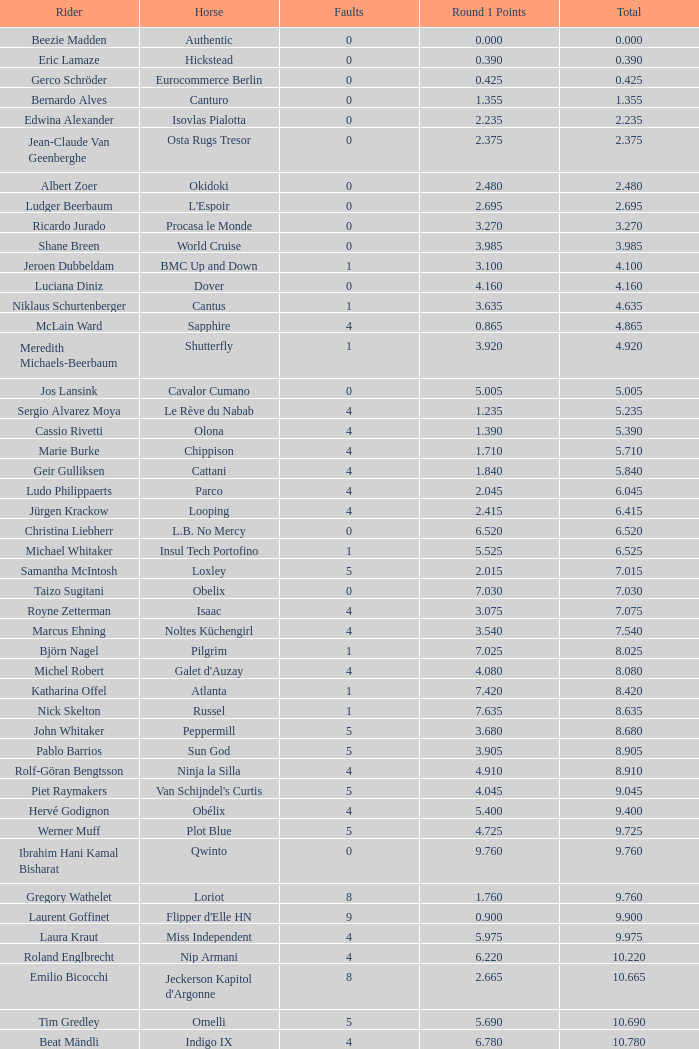Parse the table in full. {'header': ['Rider', 'Horse', 'Faults', 'Round 1 Points', 'Total'], 'rows': [['Beezie Madden', 'Authentic', '0', '0.000', '0.000'], ['Eric Lamaze', 'Hickstead', '0', '0.390', '0.390'], ['Gerco Schröder', 'Eurocommerce Berlin', '0', '0.425', '0.425'], ['Bernardo Alves', 'Canturo', '0', '1.355', '1.355'], ['Edwina Alexander', 'Isovlas Pialotta', '0', '2.235', '2.235'], ['Jean-Claude Van Geenberghe', 'Osta Rugs Tresor', '0', '2.375', '2.375'], ['Albert Zoer', 'Okidoki', '0', '2.480', '2.480'], ['Ludger Beerbaum', "L'Espoir", '0', '2.695', '2.695'], ['Ricardo Jurado', 'Procasa le Monde', '0', '3.270', '3.270'], ['Shane Breen', 'World Cruise', '0', '3.985', '3.985'], ['Jeroen Dubbeldam', 'BMC Up and Down', '1', '3.100', '4.100'], ['Luciana Diniz', 'Dover', '0', '4.160', '4.160'], ['Niklaus Schurtenberger', 'Cantus', '1', '3.635', '4.635'], ['McLain Ward', 'Sapphire', '4', '0.865', '4.865'], ['Meredith Michaels-Beerbaum', 'Shutterfly', '1', '3.920', '4.920'], ['Jos Lansink', 'Cavalor Cumano', '0', '5.005', '5.005'], ['Sergio Alvarez Moya', 'Le Rève du Nabab', '4', '1.235', '5.235'], ['Cassio Rivetti', 'Olona', '4', '1.390', '5.390'], ['Marie Burke', 'Chippison', '4', '1.710', '5.710'], ['Geir Gulliksen', 'Cattani', '4', '1.840', '5.840'], ['Ludo Philippaerts', 'Parco', '4', '2.045', '6.045'], ['Jürgen Krackow', 'Looping', '4', '2.415', '6.415'], ['Christina Liebherr', 'L.B. No Mercy', '0', '6.520', '6.520'], ['Michael Whitaker', 'Insul Tech Portofino', '1', '5.525', '6.525'], ['Samantha McIntosh', 'Loxley', '5', '2.015', '7.015'], ['Taizo Sugitani', 'Obelix', '0', '7.030', '7.030'], ['Royne Zetterman', 'Isaac', '4', '3.075', '7.075'], ['Marcus Ehning', 'Noltes Küchengirl', '4', '3.540', '7.540'], ['Björn Nagel', 'Pilgrim', '1', '7.025', '8.025'], ['Michel Robert', "Galet d'Auzay", '4', '4.080', '8.080'], ['Katharina Offel', 'Atlanta', '1', '7.420', '8.420'], ['Nick Skelton', 'Russel', '1', '7.635', '8.635'], ['John Whitaker', 'Peppermill', '5', '3.680', '8.680'], ['Pablo Barrios', 'Sun God', '5', '3.905', '8.905'], ['Rolf-Göran Bengtsson', 'Ninja la Silla', '4', '4.910', '8.910'], ['Piet Raymakers', "Van Schijndel's Curtis", '5', '4.045', '9.045'], ['Hervé Godignon', 'Obélix', '4', '5.400', '9.400'], ['Werner Muff', 'Plot Blue', '5', '4.725', '9.725'], ['Ibrahim Hani Kamal Bisharat', 'Qwinto', '0', '9.760', '9.760'], ['Gregory Wathelet', 'Loriot', '8', '1.760', '9.760'], ['Laurent Goffinet', "Flipper d'Elle HN", '9', '0.900', '9.900'], ['Laura Kraut', 'Miss Independent', '4', '5.975', '9.975'], ['Roland Englbrecht', 'Nip Armani', '4', '6.220', '10.220'], ['Emilio Bicocchi', "Jeckerson Kapitol d'Argonne", '8', '2.665', '10.665'], ['Tim Gredley', 'Omelli', '5', '5.690', '10.690'], ['Beat Mändli', 'Indigo IX', '4', '6.780', '10.780'], ['Christian Ahlmann', 'Cöster', '8', '4.000', '12.000'], ['Tina Lund', 'Carola', '9', '3.610', '12.610'], ['Max Amaya', 'Church Road', '8', '4.790', '12.790'], ['Álvaro Alfonso de Miranda Neto', 'Nike', '9', '4.235', '13.235'], ['Jesus Garmendia Echeverria', 'Maddock', '8', '5.335', '13.335'], ['Carlos Lopez', 'Instit', '10', '3.620', '13.620'], ['Juan Carlos García', 'Loro Piana Albin III', '5', '9.020', '14.020'], ['Cameron Hanley', 'Siec Hippica Kerman', '9', '5.375', '14.375'], ['Ricardo Kierkegaard', 'Rey Z', '8', '6.805', '14.805'], ['Jill Henselwood', 'Special Ed', '9', '6.165', '15.165'], ['Margie Engle', "Hidden Creek's Quervo Gold", '4', '12.065', '16.065'], ['Judy-Ann Melchoir', 'Grande Dame Z', '9', '7.310', '16.310'], ['Maria Gretzer', 'Spender S', '9', '7.385', '16.385'], ['Billy Twomey', 'Luidam', '9', '7.615', '16.615'], ['Federico Fernandez', 'Bohemio', '8', '9.610', '17.610'], ['Jonella Ligresti', 'Quinta 27', '6', '12.365', '18.365'], ['Ian Millar', 'In Style', '9', '9.370', '18.370'], ['Mikael Forsten', "BMC's Skybreaker", '12', '6.435', '18.435'], ['Sebastian Numminen', 'Sails Away', '13', '5.455', '18.455'], ['Stefan Eder', 'Cartier PSG', '12', '6.535', '18.535'], ['Dirk Demeersman', 'Clinton', '16', '2.755', '18.755'], ['Antonis Petris', 'Gredo la Daviere', '13', '6.300', '19.300'], ['Gunnar Klettenberg', 'Novesta', '9', '10.620', '19.620'], ['Syed Omar Almohdzar', 'Lui', '10', '9.820', '19.820'], ['Tony Andre Hansen', 'Camiro', '13', '7.245', '20.245'], ['Manuel Fernandez Saro', 'Quin Chin', '13', '7.465', '20.465'], ['James Wingrave', 'Agropoint Calira', '14', '6.855', '20.855'], ['Rod Brown', 'Mr. Burns', '9', '12.300', '21.300'], ['Jiri Papousek', 'La Manche T', '13', '8.440', '21.440'], ['Marcela Lobo', 'Joskin', '14', '7.600', '21.600'], ['Yuko Itakura', 'Portvliet', '9', '12.655', '21.655'], ['Zsolt Pirik', 'Havanna', '9', '13.050', '22.050'], ['Fabrice Lyon', 'Jasmine du Perron', '11', '12.760', '23.760'], ['Florian Angot', 'First de Launay', '16', '8.055', '24.055'], ['Peter McMahon', 'Kolora Stud Genoa', '9', '15.195', '24.195'], ['Giuseppe Rolli', 'Jericho de la Vie', '17', '7.910', '24.910'], ['Alberto Michan', 'Chinobampo Lavita', '13', '12.330', '25.330'], ['Hanno Ellermann', 'Poncorde', '17', '8.600', '25.600'], ['Antonio Portela Carneiro', 'Echo de Lessay', '18', '8.565', '26.565'], ['Gerfried Puck', '11th Bleeker', '21', '6.405', '27.405'], ['H.H. Prince Faisal Al-Shalan', 'Uthago', '18', '10.205', '28.205'], ['Vladimir Beletskiy', 'Rezonanz', '21', '7.725', '28.725'], ['Noora Pentti', 'Evli Cagliostro', '17', '12.455', '29.455'], ['Mohammed Al-Kumaiti', 'Al-Mutawakel', '17', '12.490', '29.490'], ['Guillermo Obligado', 'Carlson', '18', '11.545', '29.545'], ['Kamal Bahamdan', 'Campus', '17', '13.190', '30.190'], ['Veronika Macanova', 'Pompos', '13', '18.185', '31.185'], ['Vladimir Panchenko', 'Lanteno', '17', '14.460', '31.460'], ['Jose Larocca', 'Svante', '25', '8.190', '33.190'], ['Abdullah Al-Sharbatly', 'Hugo Gesmeray', '25', '8.585', '33.585'], ['Eiken Sato', 'Cayak DH', '17', '17.960', '34.960'], ['Gennadiy Gashiboyazov', 'Papirus', '28', '8.685', '36.685'], ['Karim El-Zoghby', 'Baragway', '21', '16.360', '37.360'], ['Ondrej Nagr', 'Atlas', '19', '19.865', '38.865'], ['Roger Hessen', 'Quito', '23', '17.410', '40.410'], ['Zdenek Zila', 'Pinot Grigio', '15', '26.035', '41.035'], ['Rene Lopez', 'Isky', '30', '11.675', '41.675'], ['Emmanouela Athanassiades', 'Rimini Z', '18', '24.380', '42.380'], ['Jamie Kermond', 'Stylish King', '21', '46.035', '67.035'], ['Malin Baryard-Johnsson', 'Butterfly Flip', '29', '46.035', '75.035'], ['Manuel Torres', 'Chambacunero', 'Fall', 'Fall', '5.470'], ['Krzyszlof Ludwiczak', 'HOF Schretstakens Quamiro', 'Eliminated', 'Eliminated', '7.460'], ['Grant Wilson', 'Up and Down Cellebroedersbos', 'Refusal', 'Refusal', '14.835'], ['Chris Pratt', 'Rivendell', 'Fall', 'Fall', '15.220'], ['Ariana Azcarraga', 'Sambo', 'Eliminated', 'Eliminated', '15.945'], ['Jose Alfredo Hernandez Ortega', 'Semtex P', 'Eliminated', 'Eliminated', '46.035'], ['H.R.H. Prince Abdullah Al-Soud', 'Allah Jabek', 'Retired', 'Retired', '46.035']]} Tell me the rider with 18.185 points round 1 Veronika Macanova. 